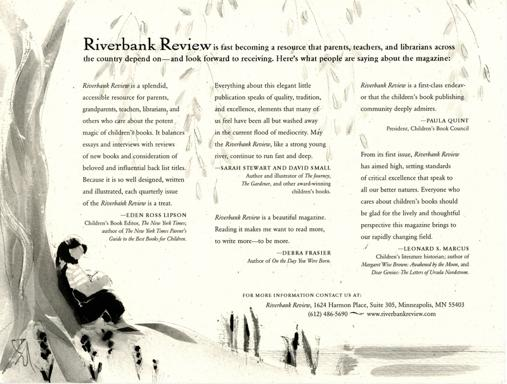Can you imagine a story inspired by this image suitable for a children's book? Certainly! One could envision a tale about a young protagonist who finds solace by the riverside, sketching the surrounding nature. The story might explore themes of creativity, the importance of solitude for personal development, and how small moments spent in nature can lead to big ideas—teaching children the value of quiet reflection and the beauty of the natural world. 